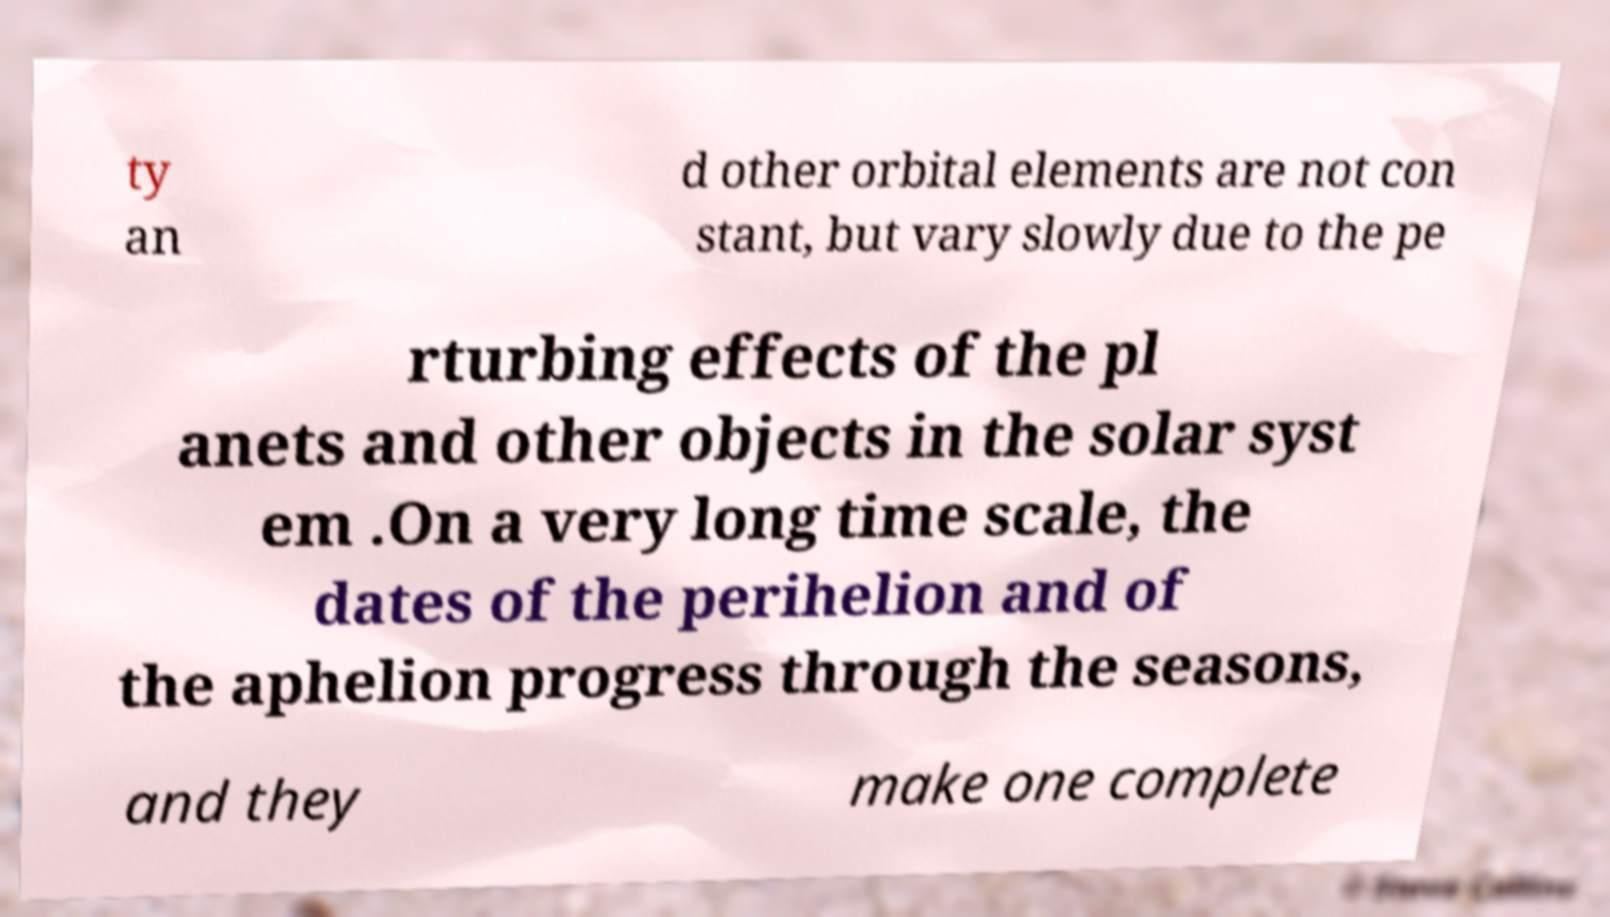Please read and relay the text visible in this image. What does it say? ty an d other orbital elements are not con stant, but vary slowly due to the pe rturbing effects of the pl anets and other objects in the solar syst em .On a very long time scale, the dates of the perihelion and of the aphelion progress through the seasons, and they make one complete 